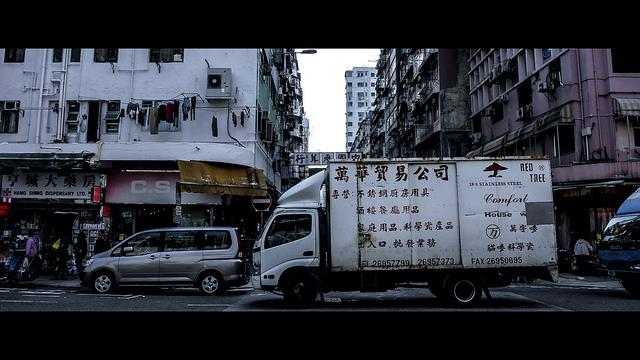Why does the large truck stop here? Please explain your reasoning. traffic. The scene depicts heavy traffic so it's easy to discern the answer. 